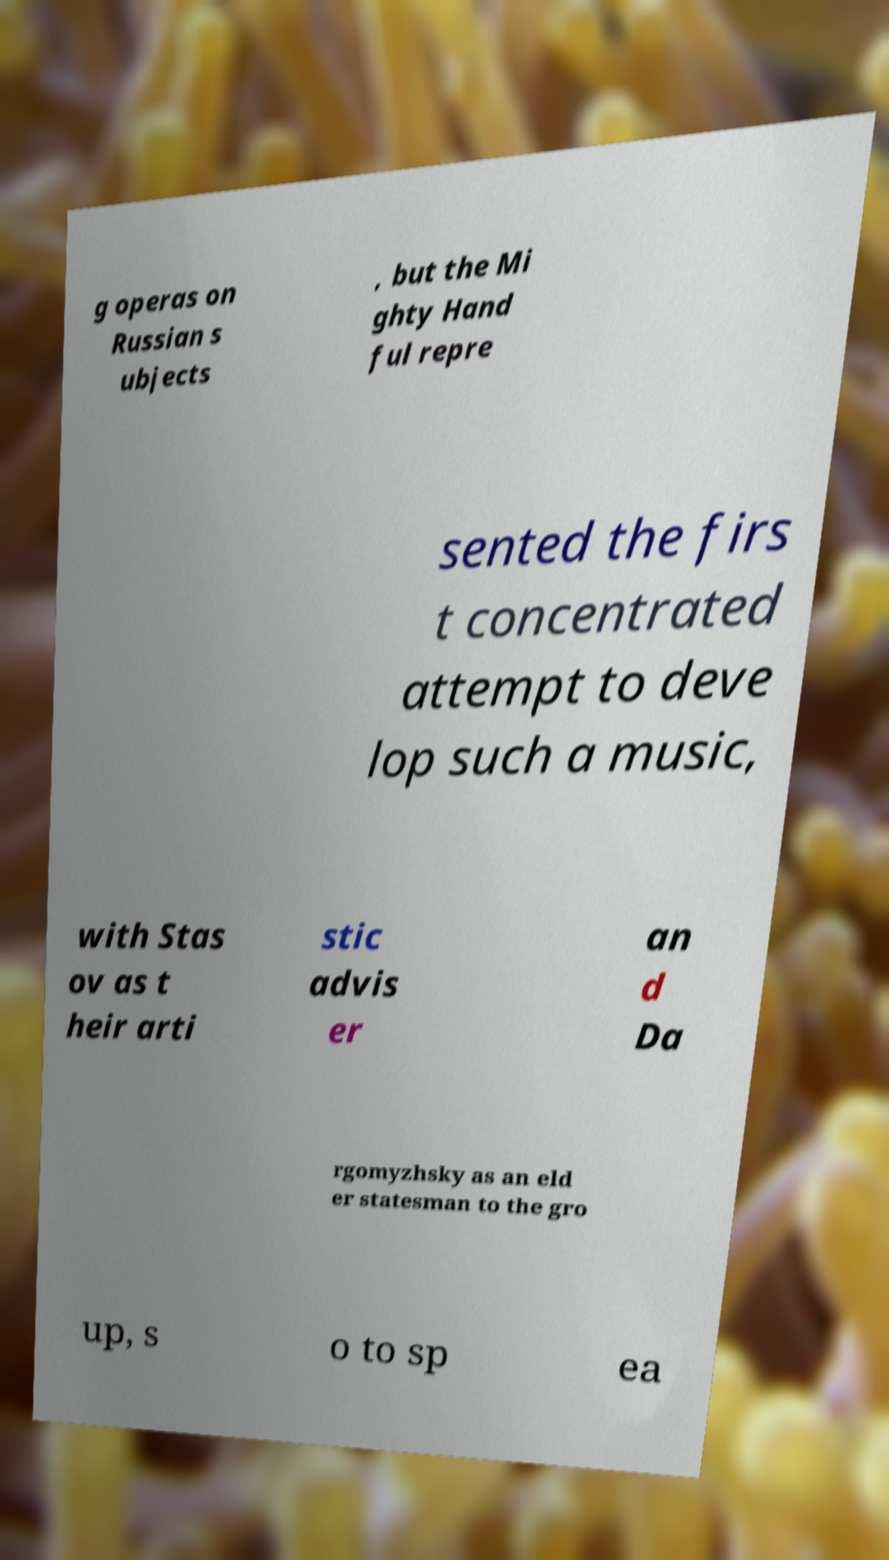I need the written content from this picture converted into text. Can you do that? g operas on Russian s ubjects , but the Mi ghty Hand ful repre sented the firs t concentrated attempt to deve lop such a music, with Stas ov as t heir arti stic advis er an d Da rgomyzhsky as an eld er statesman to the gro up, s o to sp ea 